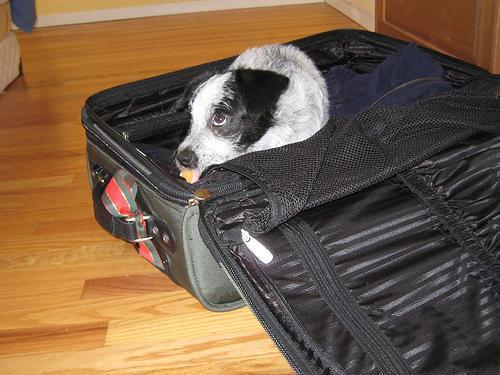How many suitcases?
Give a very brief answer. 1. How many dogs?
Give a very brief answer. 1. 